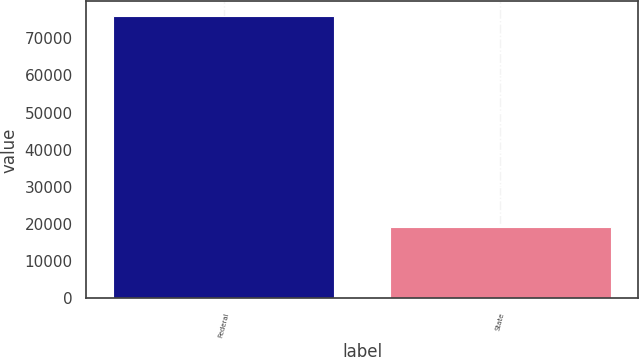<chart> <loc_0><loc_0><loc_500><loc_500><bar_chart><fcel>Federal<fcel>State<nl><fcel>76084<fcel>19076<nl></chart> 